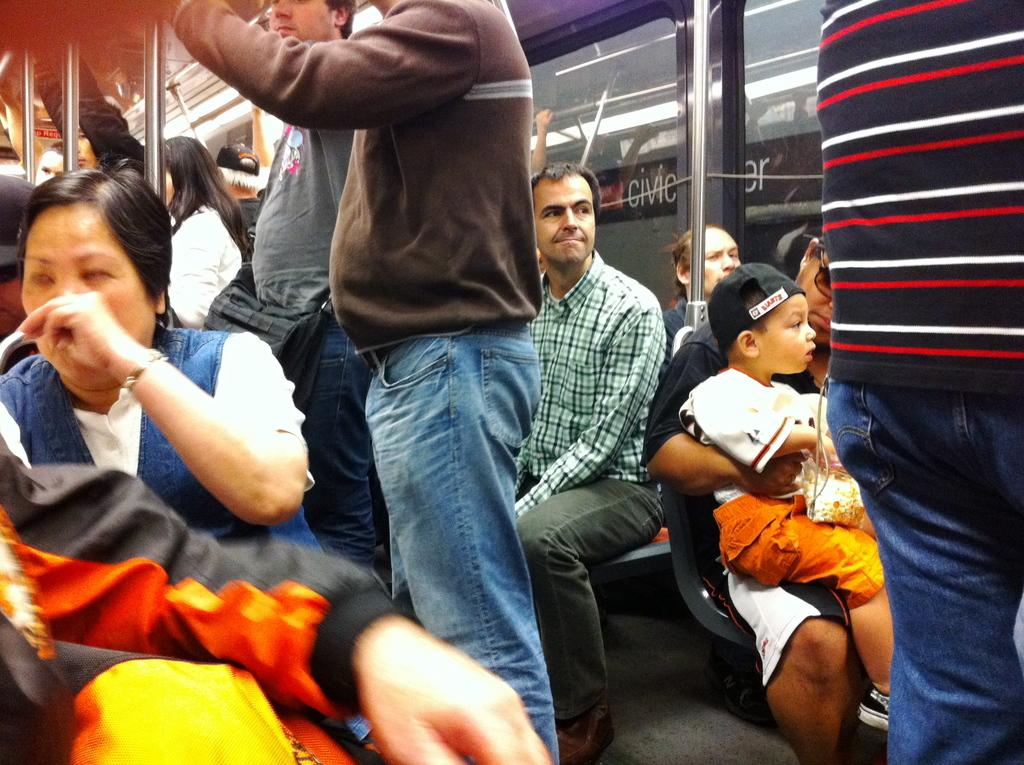What type of location is depicted in the image? The image shows the interior of a train. What are the people in the image doing? There are people standing on the floor of the train and people sitting on the seats in the train. What reward does the friend receive for helping the person in the image? There is no friend or reward present in the image; it only shows people inside a train. 